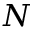<formula> <loc_0><loc_0><loc_500><loc_500>N</formula> 